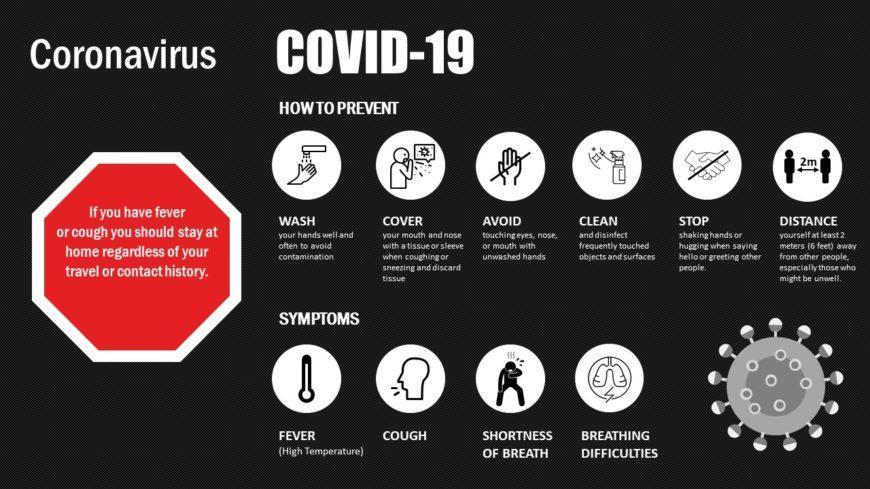What are the symptoms of COVID-19 other than fever & breathing difficulties?
Answer the question with a short phrase. COUGH, SHORTNESS OF BREATH 